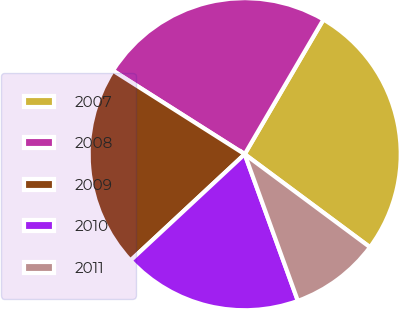Convert chart. <chart><loc_0><loc_0><loc_500><loc_500><pie_chart><fcel>2007<fcel>2008<fcel>2009<fcel>2010<fcel>2011<nl><fcel>26.74%<fcel>24.42%<fcel>20.93%<fcel>18.6%<fcel>9.3%<nl></chart> 